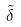Convert formula to latex. <formula><loc_0><loc_0><loc_500><loc_500>\tilde { \delta }</formula> 